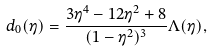Convert formula to latex. <formula><loc_0><loc_0><loc_500><loc_500>d _ { 0 } ( \eta ) = \frac { 3 \eta ^ { 4 } - 1 2 \eta ^ { 2 } + 8 } { ( 1 - \eta ^ { 2 } ) ^ { 3 } } \Lambda ( \eta ) ,</formula> 